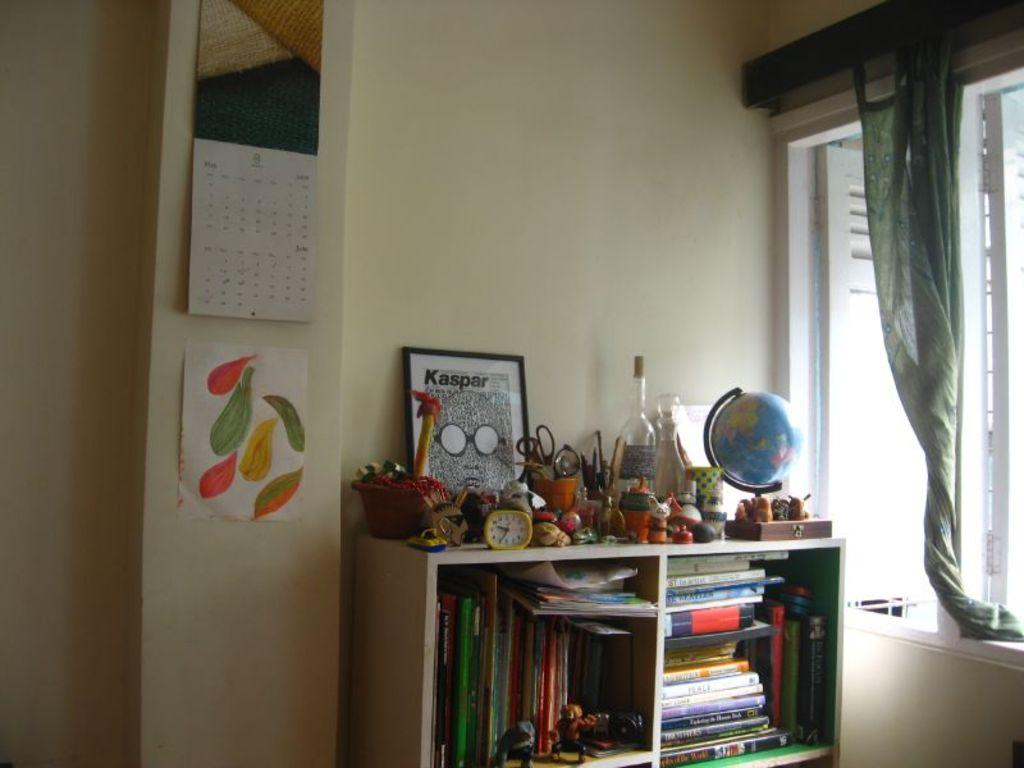<image>
Render a clear and concise summary of the photo. A framed piece of art says Kasper at the top and sits on a bookshelf among other items. 